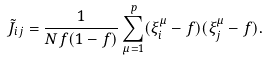Convert formula to latex. <formula><loc_0><loc_0><loc_500><loc_500>\tilde { J } _ { i j } = \frac { 1 } { N f ( 1 - f ) } \sum ^ { p } _ { \mu = 1 } ( \xi ^ { \mu } _ { i } - f ) ( \xi ^ { \mu } _ { j } - f ) .</formula> 